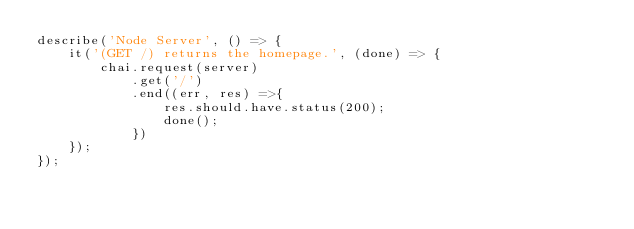Convert code to text. <code><loc_0><loc_0><loc_500><loc_500><_JavaScript_>describe('Node Server', () => {
    it('(GET /) returns the homepage.', (done) => {
        chai.request(server)
            .get('/')
            .end((err, res) =>{
                res.should.have.status(200);
                done();
            })
    });
});
</code> 